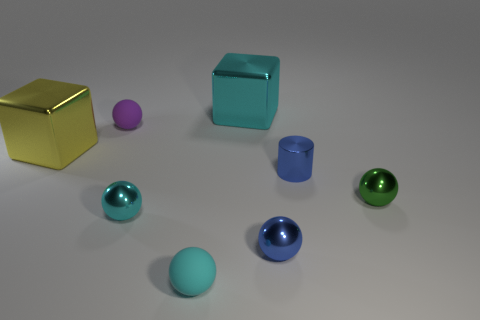Does the cylinder have the same material as the green ball?
Offer a very short reply. Yes. There is a tiny object behind the cylinder that is behind the tiny green shiny ball; what is it made of?
Make the answer very short. Rubber. Are there any large cyan shiny blocks behind the big cyan metal object?
Make the answer very short. No. Are there more metallic balls that are left of the big cyan thing than big cyan cylinders?
Ensure brevity in your answer.  Yes. Is there a small object of the same color as the tiny metal cylinder?
Your answer should be compact. Yes. What is the color of the metallic cylinder that is the same size as the purple rubber thing?
Keep it short and to the point. Blue. Are there any purple matte objects that are right of the small ball behind the large yellow metal cube?
Offer a very short reply. No. What is the material of the small purple object that is to the right of the yellow thing?
Keep it short and to the point. Rubber. Are the cyan object left of the cyan rubber object and the sphere behind the big yellow object made of the same material?
Your response must be concise. No. Are there the same number of big metal blocks that are in front of the cyan cube and tiny cylinders that are in front of the small purple matte thing?
Make the answer very short. Yes. 